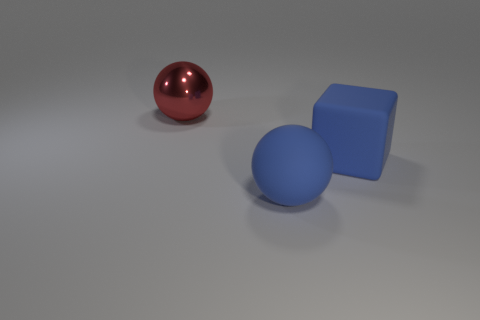Does the image seem to represent any particular theme or concept? The image presents a simple and clean composition that focuses on basic geometric shapes and contrasting colors. It may evoke themes of balance, order, and the fundamental building blocks of visual design. The use of primary colors and basic shapes can also suggest an exploration of the essential elements of art. 